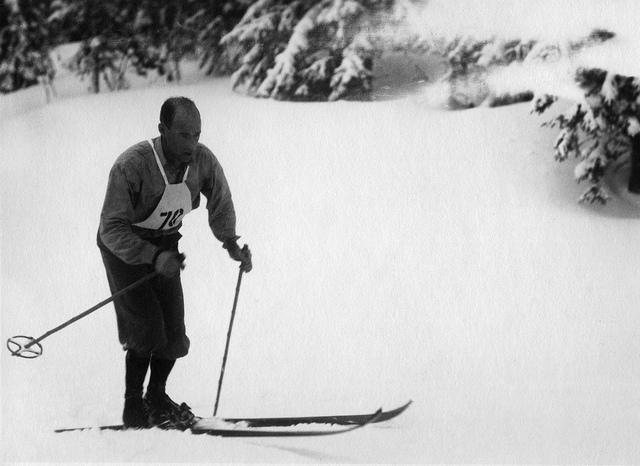What color is the photo?
Answer briefly. Black and white. What is on the ground?
Be succinct. Snow. Is the man skiing?
Be succinct. Yes. What number is in the skier's chest?
Concise answer only. 70. Is skiing fun?
Quick response, please. Yes. Is the man wearing sunglasses?
Quick response, please. No. What type of pants is the skier wearing?
Keep it brief. Knickers. Is the man dressed in warm clothes?
Be succinct. No. 